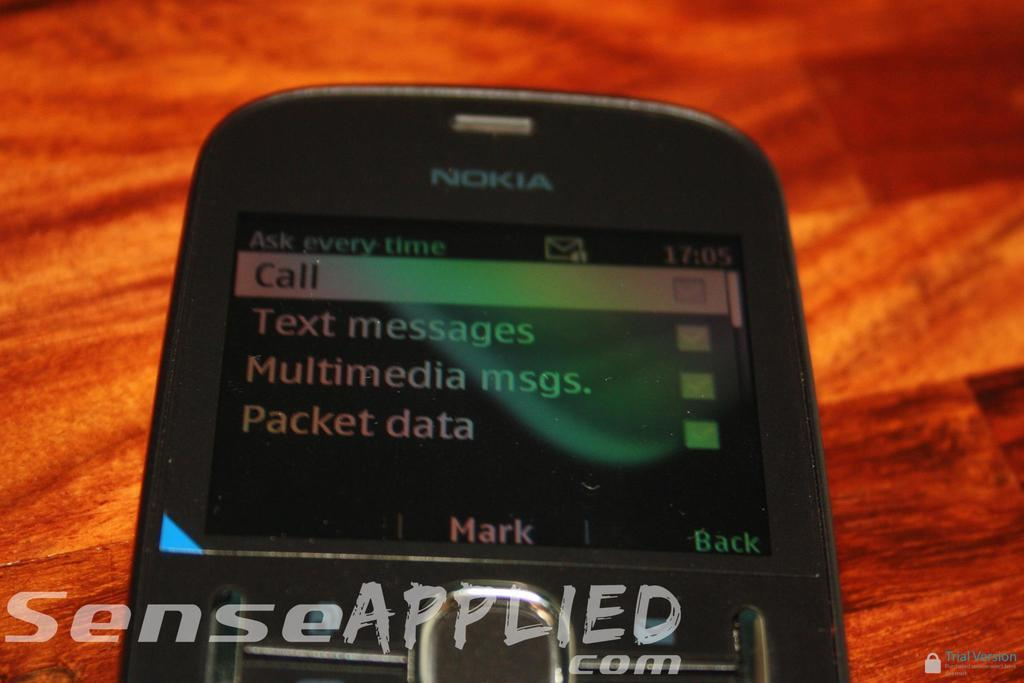<image>
Share a concise interpretation of the image provided. A Nokia cell phone that has the call screen on. 